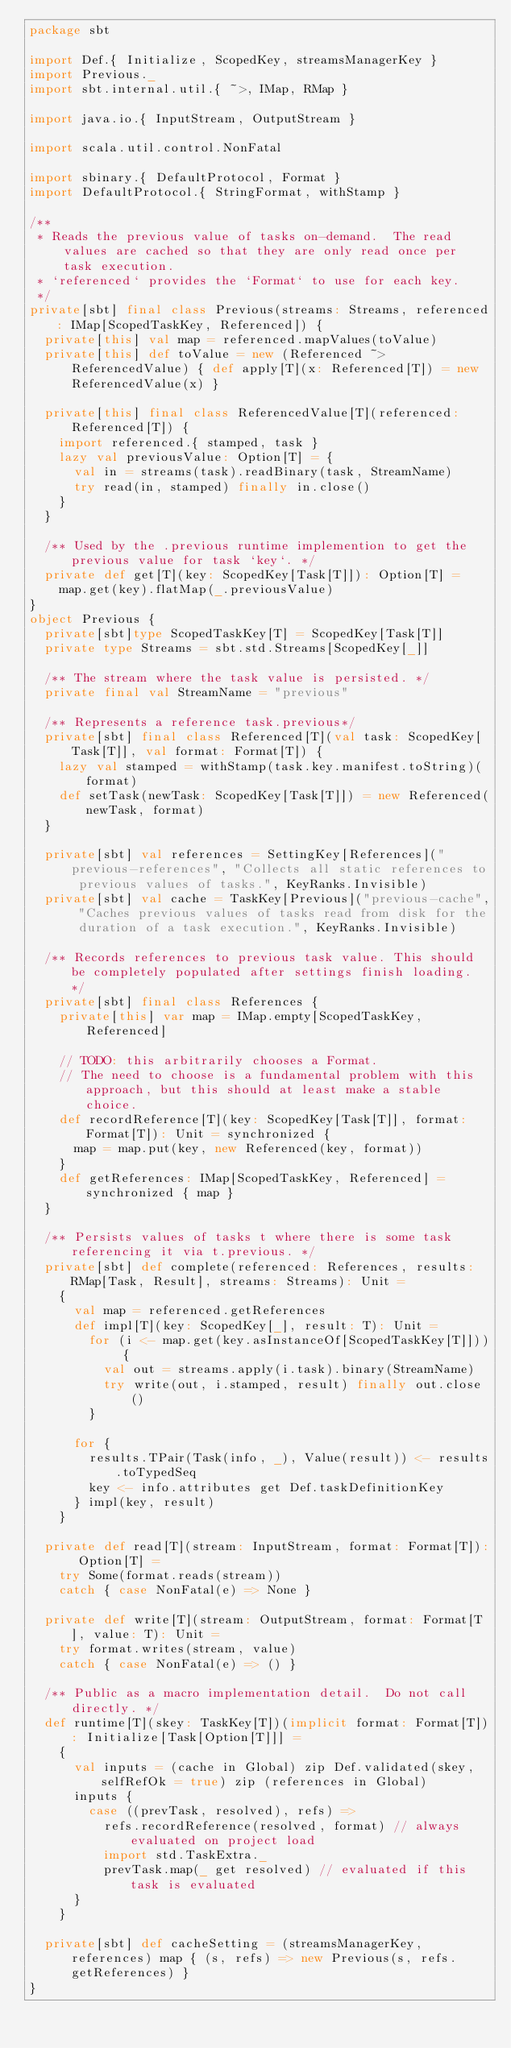Convert code to text. <code><loc_0><loc_0><loc_500><loc_500><_Scala_>package sbt

import Def.{ Initialize, ScopedKey, streamsManagerKey }
import Previous._
import sbt.internal.util.{ ~>, IMap, RMap }

import java.io.{ InputStream, OutputStream }

import scala.util.control.NonFatal

import sbinary.{ DefaultProtocol, Format }
import DefaultProtocol.{ StringFormat, withStamp }

/**
 * Reads the previous value of tasks on-demand.  The read values are cached so that they are only read once per task execution.
 * `referenced` provides the `Format` to use for each key.
 */
private[sbt] final class Previous(streams: Streams, referenced: IMap[ScopedTaskKey, Referenced]) {
  private[this] val map = referenced.mapValues(toValue)
  private[this] def toValue = new (Referenced ~> ReferencedValue) { def apply[T](x: Referenced[T]) = new ReferencedValue(x) }

  private[this] final class ReferencedValue[T](referenced: Referenced[T]) {
    import referenced.{ stamped, task }
    lazy val previousValue: Option[T] = {
      val in = streams(task).readBinary(task, StreamName)
      try read(in, stamped) finally in.close()
    }
  }

  /** Used by the .previous runtime implemention to get the previous value for task `key`. */
  private def get[T](key: ScopedKey[Task[T]]): Option[T] =
    map.get(key).flatMap(_.previousValue)
}
object Previous {
  private[sbt]type ScopedTaskKey[T] = ScopedKey[Task[T]]
  private type Streams = sbt.std.Streams[ScopedKey[_]]

  /** The stream where the task value is persisted. */
  private final val StreamName = "previous"

  /** Represents a reference task.previous*/
  private[sbt] final class Referenced[T](val task: ScopedKey[Task[T]], val format: Format[T]) {
    lazy val stamped = withStamp(task.key.manifest.toString)(format)
    def setTask(newTask: ScopedKey[Task[T]]) = new Referenced(newTask, format)
  }

  private[sbt] val references = SettingKey[References]("previous-references", "Collects all static references to previous values of tasks.", KeyRanks.Invisible)
  private[sbt] val cache = TaskKey[Previous]("previous-cache", "Caches previous values of tasks read from disk for the duration of a task execution.", KeyRanks.Invisible)

  /** Records references to previous task value. This should be completely populated after settings finish loading. */
  private[sbt] final class References {
    private[this] var map = IMap.empty[ScopedTaskKey, Referenced]

    // TODO: this arbitrarily chooses a Format.
    // The need to choose is a fundamental problem with this approach, but this should at least make a stable choice.
    def recordReference[T](key: ScopedKey[Task[T]], format: Format[T]): Unit = synchronized {
      map = map.put(key, new Referenced(key, format))
    }
    def getReferences: IMap[ScopedTaskKey, Referenced] = synchronized { map }
  }

  /** Persists values of tasks t where there is some task referencing it via t.previous. */
  private[sbt] def complete(referenced: References, results: RMap[Task, Result], streams: Streams): Unit =
    {
      val map = referenced.getReferences
      def impl[T](key: ScopedKey[_], result: T): Unit =
        for (i <- map.get(key.asInstanceOf[ScopedTaskKey[T]])) {
          val out = streams.apply(i.task).binary(StreamName)
          try write(out, i.stamped, result) finally out.close()
        }

      for {
        results.TPair(Task(info, _), Value(result)) <- results.toTypedSeq
        key <- info.attributes get Def.taskDefinitionKey
      } impl(key, result)
    }

  private def read[T](stream: InputStream, format: Format[T]): Option[T] =
    try Some(format.reads(stream))
    catch { case NonFatal(e) => None }

  private def write[T](stream: OutputStream, format: Format[T], value: T): Unit =
    try format.writes(stream, value)
    catch { case NonFatal(e) => () }

  /** Public as a macro implementation detail.  Do not call directly. */
  def runtime[T](skey: TaskKey[T])(implicit format: Format[T]): Initialize[Task[Option[T]]] =
    {
      val inputs = (cache in Global) zip Def.validated(skey, selfRefOk = true) zip (references in Global)
      inputs {
        case ((prevTask, resolved), refs) =>
          refs.recordReference(resolved, format) // always evaluated on project load
          import std.TaskExtra._
          prevTask.map(_ get resolved) // evaluated if this task is evaluated
      }
    }

  private[sbt] def cacheSetting = (streamsManagerKey, references) map { (s, refs) => new Previous(s, refs.getReferences) }
}
</code> 